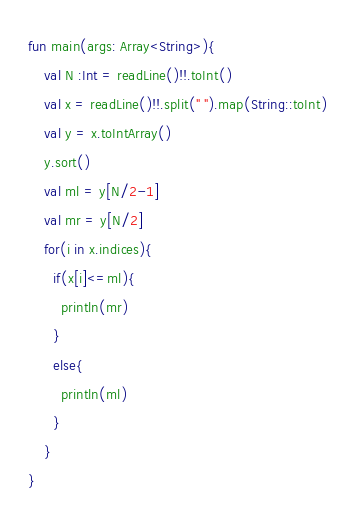<code> <loc_0><loc_0><loc_500><loc_500><_Kotlin_>fun main(args: Array<String>){
    val N :Int = readLine()!!.toInt()
    val x = readLine()!!.split(" ").map(String::toInt)
    val y = x.toIntArray()
    y.sort()
    val ml = y[N/2-1]
    val mr = y[N/2]
    for(i in x.indices){
      if(x[i]<=ml){
        println(mr)
      }
      else{
        println(ml)
      }
    }
}</code> 